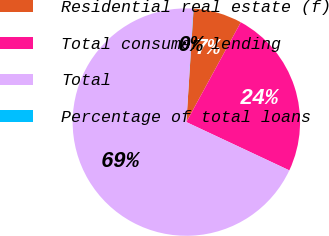Convert chart. <chart><loc_0><loc_0><loc_500><loc_500><pie_chart><fcel>Residential real estate (f)<fcel>Total consumer lending<fcel>Total<fcel>Percentage of total loans<nl><fcel>6.93%<fcel>24.03%<fcel>69.01%<fcel>0.03%<nl></chart> 